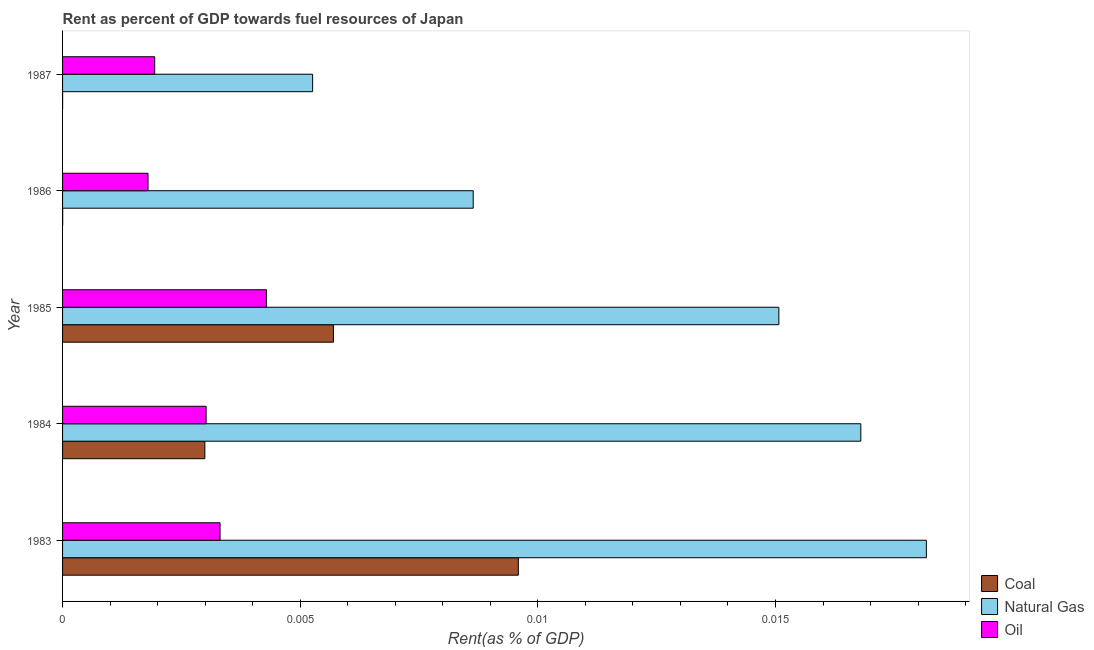How many groups of bars are there?
Your response must be concise. 5. Are the number of bars on each tick of the Y-axis equal?
Make the answer very short. Yes. How many bars are there on the 3rd tick from the top?
Your answer should be very brief. 3. What is the rent towards coal in 1985?
Offer a terse response. 0.01. Across all years, what is the maximum rent towards oil?
Your answer should be very brief. 0. Across all years, what is the minimum rent towards oil?
Provide a succinct answer. 0. What is the total rent towards coal in the graph?
Offer a terse response. 0.02. What is the difference between the rent towards coal in 1983 and that in 1984?
Ensure brevity in your answer.  0.01. What is the difference between the rent towards natural gas in 1984 and the rent towards coal in 1987?
Provide a succinct answer. 0.02. What is the average rent towards coal per year?
Your answer should be very brief. 0. In the year 1984, what is the difference between the rent towards coal and rent towards natural gas?
Your answer should be compact. -0.01. What is the ratio of the rent towards coal in 1985 to that in 1986?
Your answer should be very brief. 2206.31. Is the rent towards oil in 1984 less than that in 1987?
Offer a very short reply. No. Is the difference between the rent towards natural gas in 1983 and 1985 greater than the difference between the rent towards oil in 1983 and 1985?
Ensure brevity in your answer.  Yes. What is the difference between the highest and the second highest rent towards oil?
Give a very brief answer. 0. Is the sum of the rent towards coal in 1983 and 1985 greater than the maximum rent towards oil across all years?
Offer a terse response. Yes. What does the 1st bar from the top in 1986 represents?
Ensure brevity in your answer.  Oil. What does the 2nd bar from the bottom in 1983 represents?
Make the answer very short. Natural Gas. How many bars are there?
Provide a short and direct response. 15. How many years are there in the graph?
Make the answer very short. 5. What is the difference between two consecutive major ticks on the X-axis?
Give a very brief answer. 0.01. Are the values on the major ticks of X-axis written in scientific E-notation?
Offer a very short reply. No. How many legend labels are there?
Provide a succinct answer. 3. What is the title of the graph?
Provide a short and direct response. Rent as percent of GDP towards fuel resources of Japan. What is the label or title of the X-axis?
Provide a succinct answer. Rent(as % of GDP). What is the Rent(as % of GDP) in Coal in 1983?
Give a very brief answer. 0.01. What is the Rent(as % of GDP) of Natural Gas in 1983?
Offer a very short reply. 0.02. What is the Rent(as % of GDP) in Oil in 1983?
Offer a very short reply. 0. What is the Rent(as % of GDP) in Coal in 1984?
Ensure brevity in your answer.  0. What is the Rent(as % of GDP) in Natural Gas in 1984?
Make the answer very short. 0.02. What is the Rent(as % of GDP) of Oil in 1984?
Your answer should be very brief. 0. What is the Rent(as % of GDP) of Coal in 1985?
Provide a short and direct response. 0.01. What is the Rent(as % of GDP) of Natural Gas in 1985?
Provide a succinct answer. 0.02. What is the Rent(as % of GDP) in Oil in 1985?
Keep it short and to the point. 0. What is the Rent(as % of GDP) in Coal in 1986?
Provide a short and direct response. 2.58321740382943e-6. What is the Rent(as % of GDP) in Natural Gas in 1986?
Offer a very short reply. 0.01. What is the Rent(as % of GDP) in Oil in 1986?
Offer a terse response. 0. What is the Rent(as % of GDP) in Coal in 1987?
Your answer should be compact. 9.41219772852493e-7. What is the Rent(as % of GDP) in Natural Gas in 1987?
Provide a succinct answer. 0.01. What is the Rent(as % of GDP) of Oil in 1987?
Keep it short and to the point. 0. Across all years, what is the maximum Rent(as % of GDP) of Coal?
Provide a succinct answer. 0.01. Across all years, what is the maximum Rent(as % of GDP) in Natural Gas?
Offer a very short reply. 0.02. Across all years, what is the maximum Rent(as % of GDP) in Oil?
Your answer should be compact. 0. Across all years, what is the minimum Rent(as % of GDP) in Coal?
Provide a succinct answer. 9.41219772852493e-7. Across all years, what is the minimum Rent(as % of GDP) in Natural Gas?
Your answer should be very brief. 0.01. Across all years, what is the minimum Rent(as % of GDP) of Oil?
Offer a very short reply. 0. What is the total Rent(as % of GDP) in Coal in the graph?
Provide a short and direct response. 0.02. What is the total Rent(as % of GDP) of Natural Gas in the graph?
Offer a terse response. 0.06. What is the total Rent(as % of GDP) in Oil in the graph?
Offer a very short reply. 0.01. What is the difference between the Rent(as % of GDP) of Coal in 1983 and that in 1984?
Your answer should be very brief. 0.01. What is the difference between the Rent(as % of GDP) of Natural Gas in 1983 and that in 1984?
Offer a very short reply. 0. What is the difference between the Rent(as % of GDP) in Oil in 1983 and that in 1984?
Your response must be concise. 0. What is the difference between the Rent(as % of GDP) in Coal in 1983 and that in 1985?
Give a very brief answer. 0. What is the difference between the Rent(as % of GDP) in Natural Gas in 1983 and that in 1985?
Offer a very short reply. 0. What is the difference between the Rent(as % of GDP) of Oil in 1983 and that in 1985?
Give a very brief answer. -0. What is the difference between the Rent(as % of GDP) in Coal in 1983 and that in 1986?
Your response must be concise. 0.01. What is the difference between the Rent(as % of GDP) of Natural Gas in 1983 and that in 1986?
Make the answer very short. 0.01. What is the difference between the Rent(as % of GDP) in Oil in 1983 and that in 1986?
Make the answer very short. 0. What is the difference between the Rent(as % of GDP) in Coal in 1983 and that in 1987?
Offer a terse response. 0.01. What is the difference between the Rent(as % of GDP) in Natural Gas in 1983 and that in 1987?
Your answer should be very brief. 0.01. What is the difference between the Rent(as % of GDP) of Oil in 1983 and that in 1987?
Provide a short and direct response. 0. What is the difference between the Rent(as % of GDP) of Coal in 1984 and that in 1985?
Give a very brief answer. -0. What is the difference between the Rent(as % of GDP) of Natural Gas in 1984 and that in 1985?
Make the answer very short. 0. What is the difference between the Rent(as % of GDP) in Oil in 1984 and that in 1985?
Keep it short and to the point. -0. What is the difference between the Rent(as % of GDP) of Coal in 1984 and that in 1986?
Ensure brevity in your answer.  0. What is the difference between the Rent(as % of GDP) of Natural Gas in 1984 and that in 1986?
Your answer should be very brief. 0.01. What is the difference between the Rent(as % of GDP) in Oil in 1984 and that in 1986?
Offer a very short reply. 0. What is the difference between the Rent(as % of GDP) of Coal in 1984 and that in 1987?
Make the answer very short. 0. What is the difference between the Rent(as % of GDP) in Natural Gas in 1984 and that in 1987?
Offer a terse response. 0.01. What is the difference between the Rent(as % of GDP) in Oil in 1984 and that in 1987?
Offer a very short reply. 0. What is the difference between the Rent(as % of GDP) in Coal in 1985 and that in 1986?
Your response must be concise. 0.01. What is the difference between the Rent(as % of GDP) in Natural Gas in 1985 and that in 1986?
Keep it short and to the point. 0.01. What is the difference between the Rent(as % of GDP) in Oil in 1985 and that in 1986?
Your response must be concise. 0. What is the difference between the Rent(as % of GDP) of Coal in 1985 and that in 1987?
Offer a very short reply. 0.01. What is the difference between the Rent(as % of GDP) of Natural Gas in 1985 and that in 1987?
Give a very brief answer. 0.01. What is the difference between the Rent(as % of GDP) in Oil in 1985 and that in 1987?
Offer a very short reply. 0. What is the difference between the Rent(as % of GDP) of Coal in 1986 and that in 1987?
Give a very brief answer. 0. What is the difference between the Rent(as % of GDP) in Natural Gas in 1986 and that in 1987?
Give a very brief answer. 0. What is the difference between the Rent(as % of GDP) in Oil in 1986 and that in 1987?
Make the answer very short. -0. What is the difference between the Rent(as % of GDP) of Coal in 1983 and the Rent(as % of GDP) of Natural Gas in 1984?
Give a very brief answer. -0.01. What is the difference between the Rent(as % of GDP) in Coal in 1983 and the Rent(as % of GDP) in Oil in 1984?
Your response must be concise. 0.01. What is the difference between the Rent(as % of GDP) of Natural Gas in 1983 and the Rent(as % of GDP) of Oil in 1984?
Give a very brief answer. 0.02. What is the difference between the Rent(as % of GDP) in Coal in 1983 and the Rent(as % of GDP) in Natural Gas in 1985?
Offer a very short reply. -0.01. What is the difference between the Rent(as % of GDP) of Coal in 1983 and the Rent(as % of GDP) of Oil in 1985?
Provide a succinct answer. 0.01. What is the difference between the Rent(as % of GDP) in Natural Gas in 1983 and the Rent(as % of GDP) in Oil in 1985?
Your response must be concise. 0.01. What is the difference between the Rent(as % of GDP) of Coal in 1983 and the Rent(as % of GDP) of Natural Gas in 1986?
Keep it short and to the point. 0. What is the difference between the Rent(as % of GDP) of Coal in 1983 and the Rent(as % of GDP) of Oil in 1986?
Provide a short and direct response. 0.01. What is the difference between the Rent(as % of GDP) of Natural Gas in 1983 and the Rent(as % of GDP) of Oil in 1986?
Provide a short and direct response. 0.02. What is the difference between the Rent(as % of GDP) of Coal in 1983 and the Rent(as % of GDP) of Natural Gas in 1987?
Offer a terse response. 0. What is the difference between the Rent(as % of GDP) in Coal in 1983 and the Rent(as % of GDP) in Oil in 1987?
Your answer should be compact. 0.01. What is the difference between the Rent(as % of GDP) in Natural Gas in 1983 and the Rent(as % of GDP) in Oil in 1987?
Your answer should be compact. 0.02. What is the difference between the Rent(as % of GDP) in Coal in 1984 and the Rent(as % of GDP) in Natural Gas in 1985?
Ensure brevity in your answer.  -0.01. What is the difference between the Rent(as % of GDP) of Coal in 1984 and the Rent(as % of GDP) of Oil in 1985?
Keep it short and to the point. -0. What is the difference between the Rent(as % of GDP) in Natural Gas in 1984 and the Rent(as % of GDP) in Oil in 1985?
Your response must be concise. 0.01. What is the difference between the Rent(as % of GDP) in Coal in 1984 and the Rent(as % of GDP) in Natural Gas in 1986?
Provide a succinct answer. -0.01. What is the difference between the Rent(as % of GDP) of Coal in 1984 and the Rent(as % of GDP) of Oil in 1986?
Provide a short and direct response. 0. What is the difference between the Rent(as % of GDP) in Natural Gas in 1984 and the Rent(as % of GDP) in Oil in 1986?
Give a very brief answer. 0.01. What is the difference between the Rent(as % of GDP) in Coal in 1984 and the Rent(as % of GDP) in Natural Gas in 1987?
Ensure brevity in your answer.  -0. What is the difference between the Rent(as % of GDP) in Coal in 1984 and the Rent(as % of GDP) in Oil in 1987?
Your answer should be very brief. 0. What is the difference between the Rent(as % of GDP) in Natural Gas in 1984 and the Rent(as % of GDP) in Oil in 1987?
Give a very brief answer. 0.01. What is the difference between the Rent(as % of GDP) in Coal in 1985 and the Rent(as % of GDP) in Natural Gas in 1986?
Give a very brief answer. -0. What is the difference between the Rent(as % of GDP) in Coal in 1985 and the Rent(as % of GDP) in Oil in 1986?
Offer a terse response. 0. What is the difference between the Rent(as % of GDP) in Natural Gas in 1985 and the Rent(as % of GDP) in Oil in 1986?
Provide a short and direct response. 0.01. What is the difference between the Rent(as % of GDP) of Coal in 1985 and the Rent(as % of GDP) of Oil in 1987?
Your answer should be very brief. 0. What is the difference between the Rent(as % of GDP) in Natural Gas in 1985 and the Rent(as % of GDP) in Oil in 1987?
Your answer should be compact. 0.01. What is the difference between the Rent(as % of GDP) in Coal in 1986 and the Rent(as % of GDP) in Natural Gas in 1987?
Provide a succinct answer. -0.01. What is the difference between the Rent(as % of GDP) of Coal in 1986 and the Rent(as % of GDP) of Oil in 1987?
Your response must be concise. -0. What is the difference between the Rent(as % of GDP) in Natural Gas in 1986 and the Rent(as % of GDP) in Oil in 1987?
Keep it short and to the point. 0.01. What is the average Rent(as % of GDP) in Coal per year?
Your answer should be very brief. 0. What is the average Rent(as % of GDP) of Natural Gas per year?
Ensure brevity in your answer.  0.01. What is the average Rent(as % of GDP) of Oil per year?
Provide a short and direct response. 0. In the year 1983, what is the difference between the Rent(as % of GDP) of Coal and Rent(as % of GDP) of Natural Gas?
Offer a terse response. -0.01. In the year 1983, what is the difference between the Rent(as % of GDP) in Coal and Rent(as % of GDP) in Oil?
Your response must be concise. 0.01. In the year 1983, what is the difference between the Rent(as % of GDP) in Natural Gas and Rent(as % of GDP) in Oil?
Offer a terse response. 0.01. In the year 1984, what is the difference between the Rent(as % of GDP) in Coal and Rent(as % of GDP) in Natural Gas?
Your response must be concise. -0.01. In the year 1984, what is the difference between the Rent(as % of GDP) in Coal and Rent(as % of GDP) in Oil?
Your answer should be compact. -0. In the year 1984, what is the difference between the Rent(as % of GDP) of Natural Gas and Rent(as % of GDP) of Oil?
Offer a terse response. 0.01. In the year 1985, what is the difference between the Rent(as % of GDP) in Coal and Rent(as % of GDP) in Natural Gas?
Provide a succinct answer. -0.01. In the year 1985, what is the difference between the Rent(as % of GDP) of Coal and Rent(as % of GDP) of Oil?
Keep it short and to the point. 0. In the year 1985, what is the difference between the Rent(as % of GDP) of Natural Gas and Rent(as % of GDP) of Oil?
Ensure brevity in your answer.  0.01. In the year 1986, what is the difference between the Rent(as % of GDP) of Coal and Rent(as % of GDP) of Natural Gas?
Provide a short and direct response. -0.01. In the year 1986, what is the difference between the Rent(as % of GDP) in Coal and Rent(as % of GDP) in Oil?
Provide a succinct answer. -0. In the year 1986, what is the difference between the Rent(as % of GDP) in Natural Gas and Rent(as % of GDP) in Oil?
Your response must be concise. 0.01. In the year 1987, what is the difference between the Rent(as % of GDP) in Coal and Rent(as % of GDP) in Natural Gas?
Your response must be concise. -0.01. In the year 1987, what is the difference between the Rent(as % of GDP) of Coal and Rent(as % of GDP) of Oil?
Offer a terse response. -0. In the year 1987, what is the difference between the Rent(as % of GDP) of Natural Gas and Rent(as % of GDP) of Oil?
Offer a very short reply. 0. What is the ratio of the Rent(as % of GDP) in Coal in 1983 to that in 1984?
Your answer should be very brief. 3.2. What is the ratio of the Rent(as % of GDP) in Natural Gas in 1983 to that in 1984?
Provide a succinct answer. 1.08. What is the ratio of the Rent(as % of GDP) of Oil in 1983 to that in 1984?
Offer a terse response. 1.1. What is the ratio of the Rent(as % of GDP) in Coal in 1983 to that in 1985?
Offer a terse response. 1.68. What is the ratio of the Rent(as % of GDP) of Natural Gas in 1983 to that in 1985?
Provide a succinct answer. 1.21. What is the ratio of the Rent(as % of GDP) of Oil in 1983 to that in 1985?
Your response must be concise. 0.77. What is the ratio of the Rent(as % of GDP) of Coal in 1983 to that in 1986?
Your response must be concise. 3712.17. What is the ratio of the Rent(as % of GDP) in Natural Gas in 1983 to that in 1986?
Your response must be concise. 2.1. What is the ratio of the Rent(as % of GDP) of Oil in 1983 to that in 1986?
Your answer should be compact. 1.84. What is the ratio of the Rent(as % of GDP) in Coal in 1983 to that in 1987?
Offer a terse response. 1.02e+04. What is the ratio of the Rent(as % of GDP) in Natural Gas in 1983 to that in 1987?
Keep it short and to the point. 3.45. What is the ratio of the Rent(as % of GDP) of Oil in 1983 to that in 1987?
Keep it short and to the point. 1.71. What is the ratio of the Rent(as % of GDP) of Coal in 1984 to that in 1985?
Your answer should be compact. 0.53. What is the ratio of the Rent(as % of GDP) in Natural Gas in 1984 to that in 1985?
Your answer should be compact. 1.11. What is the ratio of the Rent(as % of GDP) in Oil in 1984 to that in 1985?
Your response must be concise. 0.7. What is the ratio of the Rent(as % of GDP) of Coal in 1984 to that in 1986?
Provide a short and direct response. 1158.89. What is the ratio of the Rent(as % of GDP) of Natural Gas in 1984 to that in 1986?
Offer a very short reply. 1.94. What is the ratio of the Rent(as % of GDP) in Oil in 1984 to that in 1986?
Provide a short and direct response. 1.68. What is the ratio of the Rent(as % of GDP) in Coal in 1984 to that in 1987?
Your response must be concise. 3180.62. What is the ratio of the Rent(as % of GDP) in Natural Gas in 1984 to that in 1987?
Offer a terse response. 3.19. What is the ratio of the Rent(as % of GDP) of Oil in 1984 to that in 1987?
Provide a succinct answer. 1.56. What is the ratio of the Rent(as % of GDP) of Coal in 1985 to that in 1986?
Offer a very short reply. 2206.31. What is the ratio of the Rent(as % of GDP) in Natural Gas in 1985 to that in 1986?
Provide a short and direct response. 1.74. What is the ratio of the Rent(as % of GDP) of Oil in 1985 to that in 1986?
Give a very brief answer. 2.39. What is the ratio of the Rent(as % of GDP) of Coal in 1985 to that in 1987?
Your answer should be very brief. 6055.3. What is the ratio of the Rent(as % of GDP) in Natural Gas in 1985 to that in 1987?
Keep it short and to the point. 2.86. What is the ratio of the Rent(as % of GDP) in Oil in 1985 to that in 1987?
Offer a terse response. 2.21. What is the ratio of the Rent(as % of GDP) of Coal in 1986 to that in 1987?
Keep it short and to the point. 2.74. What is the ratio of the Rent(as % of GDP) of Natural Gas in 1986 to that in 1987?
Provide a succinct answer. 1.64. What is the ratio of the Rent(as % of GDP) of Oil in 1986 to that in 1987?
Your answer should be compact. 0.93. What is the difference between the highest and the second highest Rent(as % of GDP) of Coal?
Make the answer very short. 0. What is the difference between the highest and the second highest Rent(as % of GDP) in Natural Gas?
Offer a very short reply. 0. What is the difference between the highest and the second highest Rent(as % of GDP) in Oil?
Your response must be concise. 0. What is the difference between the highest and the lowest Rent(as % of GDP) in Coal?
Ensure brevity in your answer.  0.01. What is the difference between the highest and the lowest Rent(as % of GDP) of Natural Gas?
Give a very brief answer. 0.01. What is the difference between the highest and the lowest Rent(as % of GDP) of Oil?
Ensure brevity in your answer.  0. 